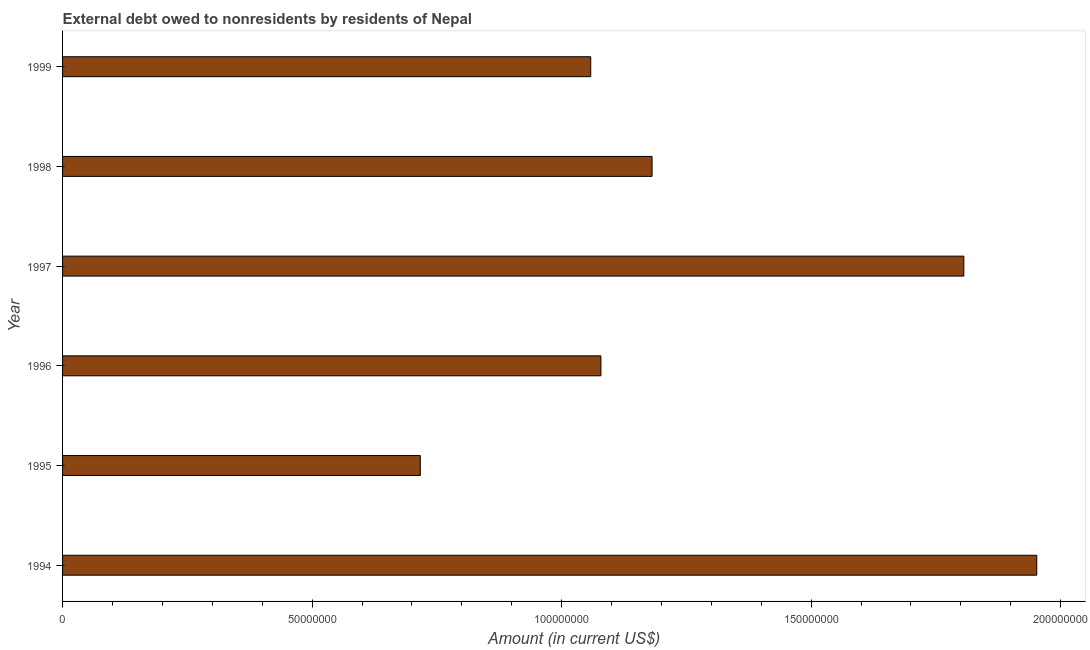Does the graph contain any zero values?
Provide a short and direct response. No. What is the title of the graph?
Make the answer very short. External debt owed to nonresidents by residents of Nepal. What is the debt in 1997?
Provide a succinct answer. 1.81e+08. Across all years, what is the maximum debt?
Provide a succinct answer. 1.95e+08. Across all years, what is the minimum debt?
Ensure brevity in your answer.  7.17e+07. In which year was the debt maximum?
Provide a succinct answer. 1994. In which year was the debt minimum?
Provide a short and direct response. 1995. What is the sum of the debt?
Give a very brief answer. 7.79e+08. What is the difference between the debt in 1996 and 1999?
Your answer should be compact. 2.04e+06. What is the average debt per year?
Offer a very short reply. 1.30e+08. What is the median debt?
Make the answer very short. 1.13e+08. In how many years, is the debt greater than 50000000 US$?
Offer a terse response. 6. What is the ratio of the debt in 1995 to that in 1999?
Offer a very short reply. 0.68. Is the difference between the debt in 1994 and 1995 greater than the difference between any two years?
Make the answer very short. Yes. What is the difference between the highest and the second highest debt?
Give a very brief answer. 1.46e+07. What is the difference between the highest and the lowest debt?
Your response must be concise. 1.24e+08. In how many years, is the debt greater than the average debt taken over all years?
Make the answer very short. 2. How many years are there in the graph?
Your response must be concise. 6. Are the values on the major ticks of X-axis written in scientific E-notation?
Your answer should be very brief. No. What is the Amount (in current US$) of 1994?
Your answer should be compact. 1.95e+08. What is the Amount (in current US$) in 1995?
Your answer should be compact. 7.17e+07. What is the Amount (in current US$) of 1996?
Make the answer very short. 1.08e+08. What is the Amount (in current US$) in 1997?
Your response must be concise. 1.81e+08. What is the Amount (in current US$) in 1998?
Provide a short and direct response. 1.18e+08. What is the Amount (in current US$) of 1999?
Provide a succinct answer. 1.06e+08. What is the difference between the Amount (in current US$) in 1994 and 1995?
Provide a succinct answer. 1.24e+08. What is the difference between the Amount (in current US$) in 1994 and 1996?
Offer a terse response. 8.73e+07. What is the difference between the Amount (in current US$) in 1994 and 1997?
Offer a terse response. 1.46e+07. What is the difference between the Amount (in current US$) in 1994 and 1998?
Your answer should be very brief. 7.71e+07. What is the difference between the Amount (in current US$) in 1994 and 1999?
Give a very brief answer. 8.94e+07. What is the difference between the Amount (in current US$) in 1995 and 1996?
Give a very brief answer. -3.62e+07. What is the difference between the Amount (in current US$) in 1995 and 1997?
Offer a very short reply. -1.09e+08. What is the difference between the Amount (in current US$) in 1995 and 1998?
Provide a succinct answer. -4.64e+07. What is the difference between the Amount (in current US$) in 1995 and 1999?
Your answer should be compact. -3.41e+07. What is the difference between the Amount (in current US$) in 1996 and 1997?
Ensure brevity in your answer.  -7.27e+07. What is the difference between the Amount (in current US$) in 1996 and 1998?
Your answer should be compact. -1.02e+07. What is the difference between the Amount (in current US$) in 1996 and 1999?
Your response must be concise. 2.04e+06. What is the difference between the Amount (in current US$) in 1997 and 1998?
Ensure brevity in your answer.  6.25e+07. What is the difference between the Amount (in current US$) in 1997 and 1999?
Ensure brevity in your answer.  7.48e+07. What is the difference between the Amount (in current US$) in 1998 and 1999?
Make the answer very short. 1.23e+07. What is the ratio of the Amount (in current US$) in 1994 to that in 1995?
Your answer should be very brief. 2.72. What is the ratio of the Amount (in current US$) in 1994 to that in 1996?
Your answer should be very brief. 1.81. What is the ratio of the Amount (in current US$) in 1994 to that in 1997?
Your answer should be very brief. 1.08. What is the ratio of the Amount (in current US$) in 1994 to that in 1998?
Give a very brief answer. 1.65. What is the ratio of the Amount (in current US$) in 1994 to that in 1999?
Your response must be concise. 1.84. What is the ratio of the Amount (in current US$) in 1995 to that in 1996?
Your response must be concise. 0.67. What is the ratio of the Amount (in current US$) in 1995 to that in 1997?
Keep it short and to the point. 0.4. What is the ratio of the Amount (in current US$) in 1995 to that in 1998?
Your response must be concise. 0.61. What is the ratio of the Amount (in current US$) in 1995 to that in 1999?
Ensure brevity in your answer.  0.68. What is the ratio of the Amount (in current US$) in 1996 to that in 1997?
Make the answer very short. 0.6. What is the ratio of the Amount (in current US$) in 1996 to that in 1998?
Ensure brevity in your answer.  0.91. What is the ratio of the Amount (in current US$) in 1996 to that in 1999?
Your answer should be very brief. 1.02. What is the ratio of the Amount (in current US$) in 1997 to that in 1998?
Give a very brief answer. 1.53. What is the ratio of the Amount (in current US$) in 1997 to that in 1999?
Give a very brief answer. 1.71. What is the ratio of the Amount (in current US$) in 1998 to that in 1999?
Your answer should be compact. 1.12. 